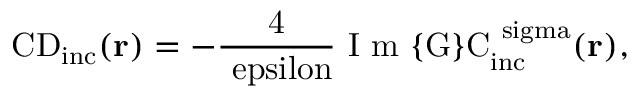<formula> <loc_0><loc_0><loc_500><loc_500>{ C D } _ { \mathrm { i n c } } ( { r } ) = - \frac { 4 } { \ e p s i l o n } \mathrm { I m } \{ G \} C _ { \mathrm { i n c } } ^ { \ s i g m a } ( { r } ) ,</formula> 